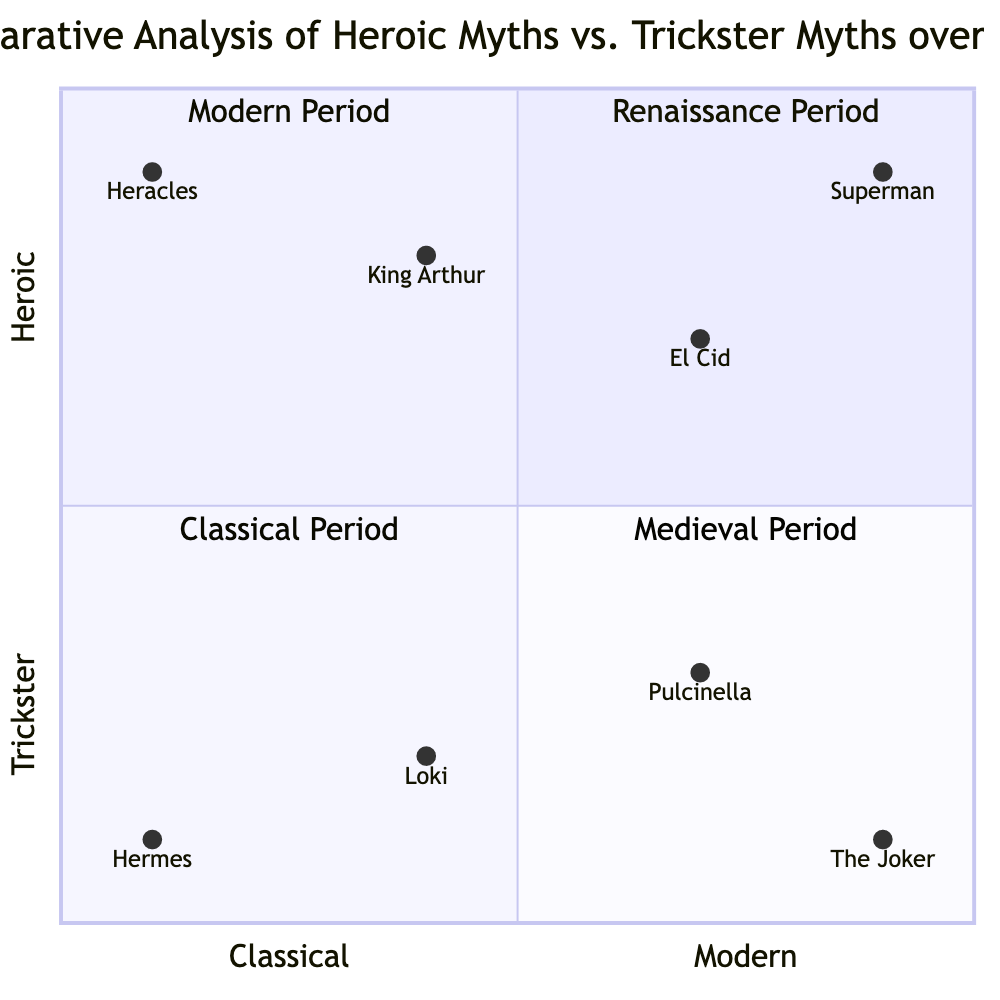What is the myth associated with the Heroic type in the Classical Period? The quadrant for the Classical Period contains the Heroic myth of Heracles.
Answer: Heracles What characteristics define the Trickster myth of Loki? Loki, from the Medieval Period, is characterized by deception, shapeshifting, and chaos.
Answer: Deception, shapeshifting, chaos Which Heroic myth appears in the Modern Period? The quadrant for the Modern Period includes the Heroic myth of Superman.
Answer: Superman How many myths are displayed in the Renaissance Period quadrant? The Renaissance Period quadrant showcases both a Heroic myth (El Cid) and a Trickster myth (Pulcinella), making a total of two myths.
Answer: 2 Which Trickster myth is characterized by cunning and thievery? In the Classical Period, the Trickster myth associated with cunning and thievery is Hermes.
Answer: Hermes Which myth has higher representation in Heroic characteristics, King Arthur or El Cid? King Arthur is located higher on the Heroic axis than El Cid, representing stronger Heroic characteristics.
Answer: King Arthur What culture is associated with Pulcinella? The Trickster myth Pulcinella from the Renaissance Period is associated with the Italian culture.
Answer: Italian Among the myths, which has the lowest position on the Heroic axis? The Trickster myth The Joker, from the Modern Period, has the lowest position on the Heroic axis.
Answer: The Joker 